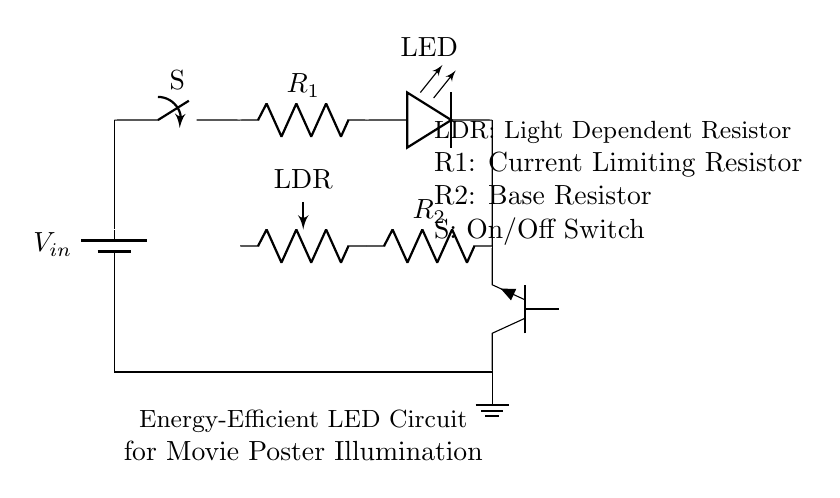What is the main function of the light-dependent resistor? The light-dependent resistor (LDR) detects ambient light levels; its resistance changes with light intensity, allowing the circuit to adjust the LED illumination accordingly.
Answer: light detection How many resistors are present in the circuit diagram? There are two resistors in the circuit: R1 and R2. R1 is the current limiting resistor and R2 is the base resistor for the transistor.
Answer: two What component is used to control the LED? The transistor is used to control the LED; it acts as a switch that turns the LED on or off based on the input from the LDR through the base resistor R2.
Answer: transistor What does the switch indicate in this circuit? The switch, labeled as S, serves as an on/off control for the entire circuit, allowing manual control over whether the LED is illuminated or not.
Answer: on/off control What might happen if the current limiting resistor is too low? If R1 is too low, the LED may receive excessive current, potentially leading to damage or burnout of the LED due to overheating.
Answer: LED damage What is the role of the transistor in relation to the LDR? The transistor amplifies the signal received from the LDR, determining whether the LED should be turned on or off based on the ambient light levels detected.
Answer: amplification What provides the power supply to the circuit? The power supply is provided by the battery, labeled as V_in, which delivers the necessary voltage for circuit operation.
Answer: battery 